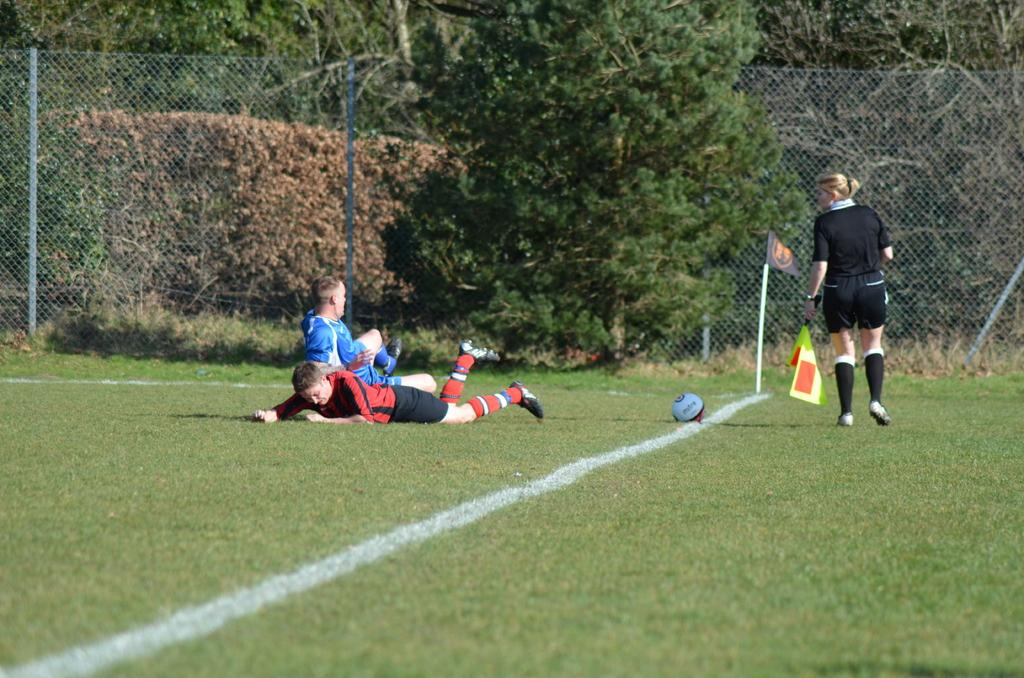What is the main setting of the image? The main setting of the image is the grassland. What are the people in the image doing? The people are on the grassland, but their specific activities are not mentioned. Can you describe the boy's position in the image? The boy is lying on the grassland. What is visible in the foreground of the image? There is a flag in the foreground of the image. What can be seen in the background of the image? There are trees and net fencing in the background of the image. What type of vase is placed on the grassland in the image? There is no vase present in the image; it features people, a boy, a flag, trees, and net fencing. Who is the writer in the image, and what are they writing about? There is no writer or any writing activity depicted in the image. 